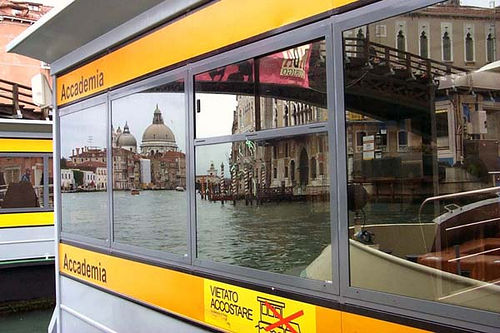Please provide the bounding box coordinate of the region this sentence describes: the left bus is grey and yellow. The bounding box coordinates for the region that describes the left bus, which is grey and yellow, are [0.0, 0.17, 0.11, 0.8]. 